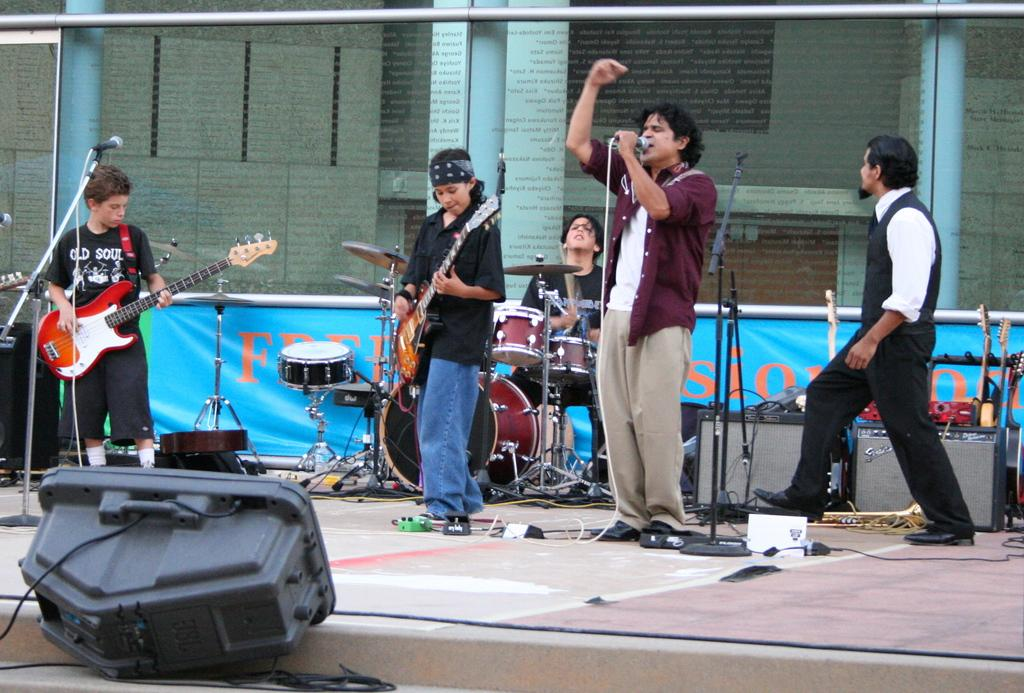How many people are in the image? There are people in the image. What are two of the people doing? Two of the people are holding guitars. What is the third person holding? One person is holding a microphone. Can you describe the man in the background of the image? The man in the background is sitting next to a drum set. What type of fruit is being used as a whistle in the image? There is no fruit being used as a whistle in the image. Can you describe the yoke that the people are wearing in the image? There are no yokes visible in the image. 